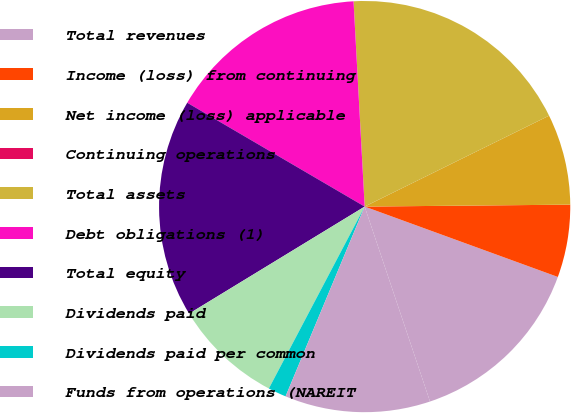Convert chart. <chart><loc_0><loc_0><loc_500><loc_500><pie_chart><fcel>Total revenues<fcel>Income (loss) from continuing<fcel>Net income (loss) applicable<fcel>Continuing operations<fcel>Total assets<fcel>Debt obligations (1)<fcel>Total equity<fcel>Dividends paid<fcel>Dividends paid per common<fcel>Funds from operations (NAREIT<nl><fcel>14.29%<fcel>5.71%<fcel>7.14%<fcel>0.0%<fcel>18.57%<fcel>15.71%<fcel>17.14%<fcel>8.57%<fcel>1.43%<fcel>11.43%<nl></chart> 